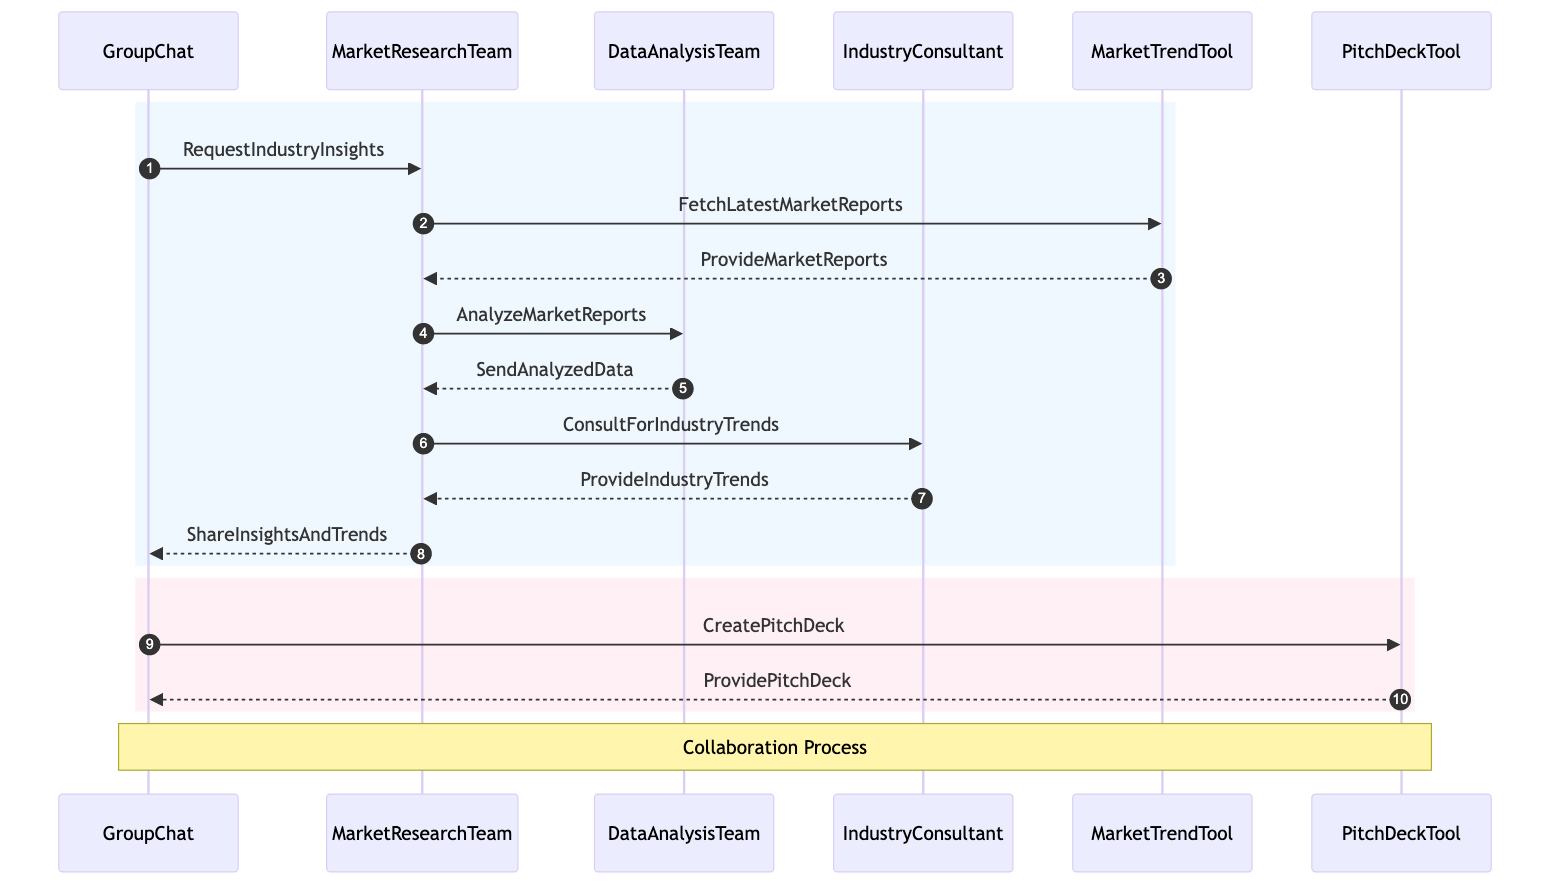What is the first message sent in the diagram? The first message sent in the diagram is from ContentCreators to MarketResearcher with the content "RequestIndustryInsights". This is indicated as the initial interaction in the sequence diagram.
Answer: RequestIndustryInsights How many actors are involved in the process? The diagram includes six actors: ContentCreators, MarketResearcher, DataAnalyst, IndustryExpert, OnlineTool, and PresentationTool. By counting the distinct participants in the diagram, we find there are six.
Answer: Six What is the last actor to receive a message in this sequence? The last actor to receive a message in the sequence is PresentationTool, which receives the message "ProvidePitchDeck" from ContentCreators after the creation of a pitch deck.
Answer: PresentationTool Which actor provides the industry trends to the MarketResearcher? The IndustryExpert provides the industry trends to the MarketResearcher, as shown in the sequence where the MarketResearcher consults the IndustryExpert for trends and receives a response.
Answer: IndustryExpert What type of tool does MarketResearcher use to fetch reports? The tool used by MarketResearcher to fetch reports is identified as MarketTrendTool. This is indicated by the message "FetchLatestMarketReports" sent to the OnlineTool.
Answer: MarketTrendTool What is the primary purpose of the sequence diagram? The primary purpose of the sequence diagram is to illustrate the process of gathering and analyzing industry insights and market trends among the groups and individuals involved. This is inferred from the flow of messages and interactions depicted in the diagram.
Answer: Gathering insights How many messages are exchanged between the actors? There are ten messages exchanged between the actors in the diagram, beginning with the request for insights and concluding with the provision of the pitch deck. Each message represents an interaction between participants throughout the described process.
Answer: Ten Which actor receives the analyzed data from the DataAnalyst? The actor that receives the analyzed data from DataAnalyst is the MarketResearcher, as indicated by the message "SendAnalyzedData" sent back to the MarketResearcher from the DataAnalyst.
Answer: MarketResearcher What does ContentCreators create after the insights are shared? After the insights are shared by the MarketResearcher, the ContentCreators create a pitch deck, as indicated by the message "CreatePitchDeck" directed to the PresentationTool.
Answer: PitchDeck 